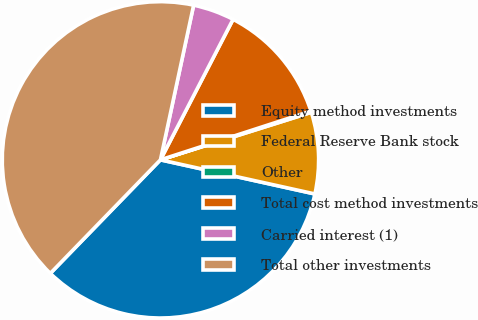<chart> <loc_0><loc_0><loc_500><loc_500><pie_chart><fcel>Equity method investments<fcel>Federal Reserve Bank stock<fcel>Other<fcel>Total cost method investments<fcel>Carried interest (1)<fcel>Total other investments<nl><fcel>33.8%<fcel>8.32%<fcel>0.13%<fcel>12.42%<fcel>4.23%<fcel>41.11%<nl></chart> 